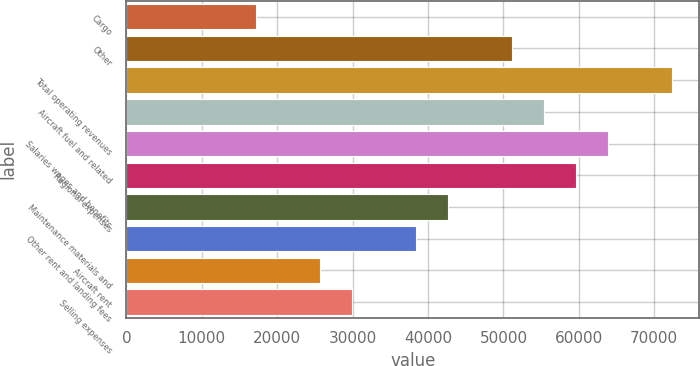Convert chart. <chart><loc_0><loc_0><loc_500><loc_500><bar_chart><fcel>Cargo<fcel>Other<fcel>Total operating revenues<fcel>Aircraft fuel and related<fcel>Salaries wages and benefits<fcel>Regional expenses<fcel>Maintenance materials and<fcel>Other rent and landing fees<fcel>Aircraft rent<fcel>Selling expenses<nl><fcel>17117.8<fcel>51107.4<fcel>72350.9<fcel>55356.1<fcel>63853.5<fcel>59604.8<fcel>42610<fcel>38361.3<fcel>25615.2<fcel>29863.9<nl></chart> 